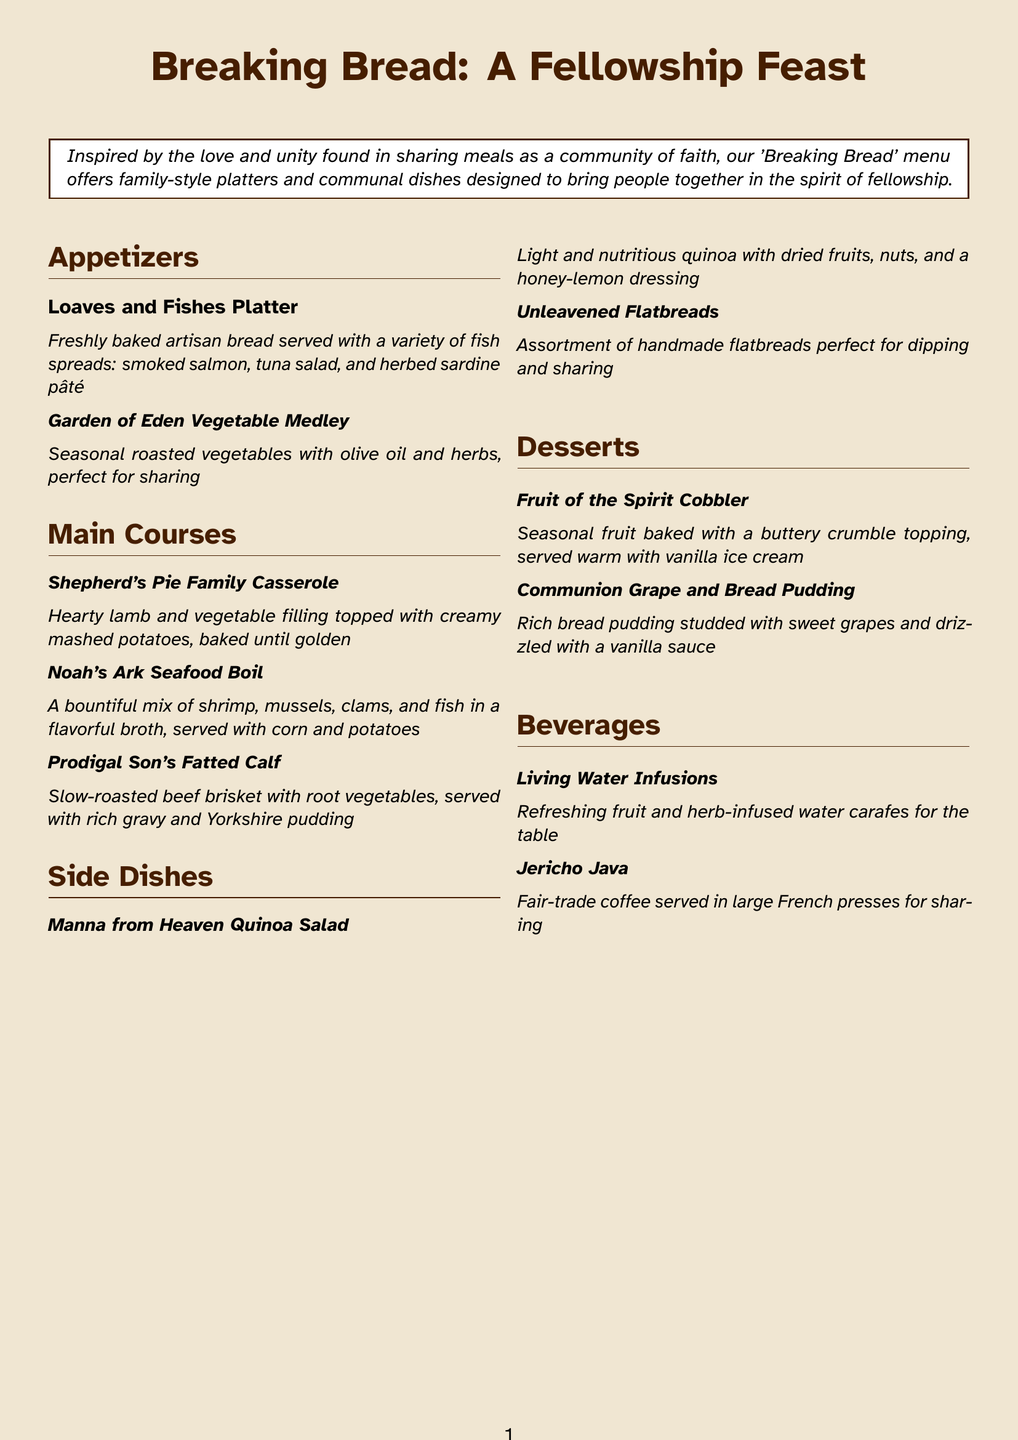what is the name of the menu? The name of the menu is found at the top of the document.
Answer: Breaking Bread: A Fellowship Feast what dish features seasonal roasted vegetables? The dish with seasonal roasted vegetables is listed under appetizers.
Answer: Garden of Eden Vegetable Medley how many main courses are listed? The total number of main courses is counted from the section provided in the document.
Answer: three what type of salad is served as a side dish? The type of salad is indicated in the side dishes section of the menu.
Answer: Manna from Heaven Quinoa Salad what is included in the Noah's Ark Seafood Boil? The ingredients of this dish are listed together in the main courses section.
Answer: shrimp, mussels, clams, and fish which dessert is drizzled with vanilla sauce? The dessert description mentions the sauce, found in the desserts section.
Answer: Communion Grape and Bread Pudding what is served as a beverage with large French presses? This beverage is specifically indicated in the beverages section.
Answer: Jericho Java how are the appetizers intended to be enjoyed? The intention behind the appetizers is specified in the first part of the menu description.
Answer: perfect for sharing 